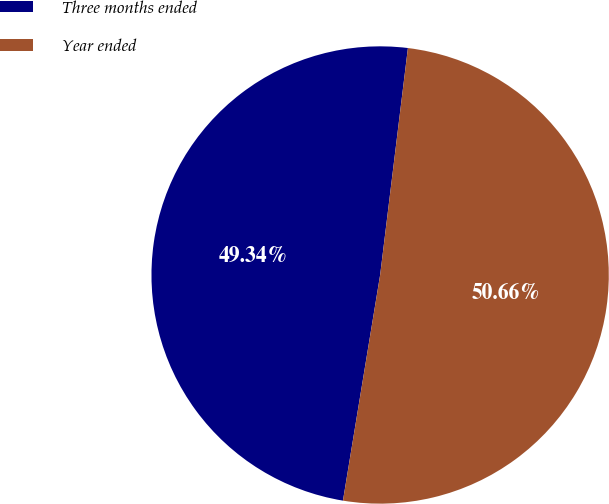Convert chart. <chart><loc_0><loc_0><loc_500><loc_500><pie_chart><fcel>Three months ended<fcel>Year ended<nl><fcel>49.34%<fcel>50.66%<nl></chart> 